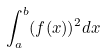<formula> <loc_0><loc_0><loc_500><loc_500>\int _ { a } ^ { b } ( f ( x ) ) ^ { 2 } d x</formula> 